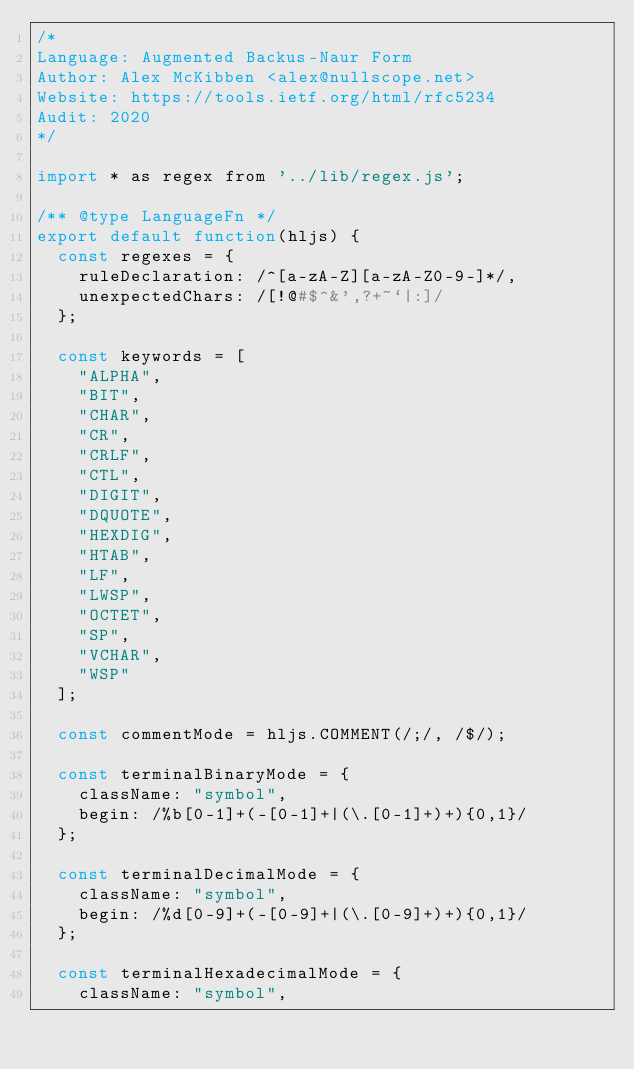Convert code to text. <code><loc_0><loc_0><loc_500><loc_500><_JavaScript_>/*
Language: Augmented Backus-Naur Form
Author: Alex McKibben <alex@nullscope.net>
Website: https://tools.ietf.org/html/rfc5234
Audit: 2020
*/

import * as regex from '../lib/regex.js';

/** @type LanguageFn */
export default function(hljs) {
  const regexes = {
    ruleDeclaration: /^[a-zA-Z][a-zA-Z0-9-]*/,
    unexpectedChars: /[!@#$^&',?+~`|:]/
  };

  const keywords = [
    "ALPHA",
    "BIT",
    "CHAR",
    "CR",
    "CRLF",
    "CTL",
    "DIGIT",
    "DQUOTE",
    "HEXDIG",
    "HTAB",
    "LF",
    "LWSP",
    "OCTET",
    "SP",
    "VCHAR",
    "WSP"
  ];

  const commentMode = hljs.COMMENT(/;/, /$/);

  const terminalBinaryMode = {
    className: "symbol",
    begin: /%b[0-1]+(-[0-1]+|(\.[0-1]+)+){0,1}/
  };

  const terminalDecimalMode = {
    className: "symbol",
    begin: /%d[0-9]+(-[0-9]+|(\.[0-9]+)+){0,1}/
  };

  const terminalHexadecimalMode = {
    className: "symbol",</code> 